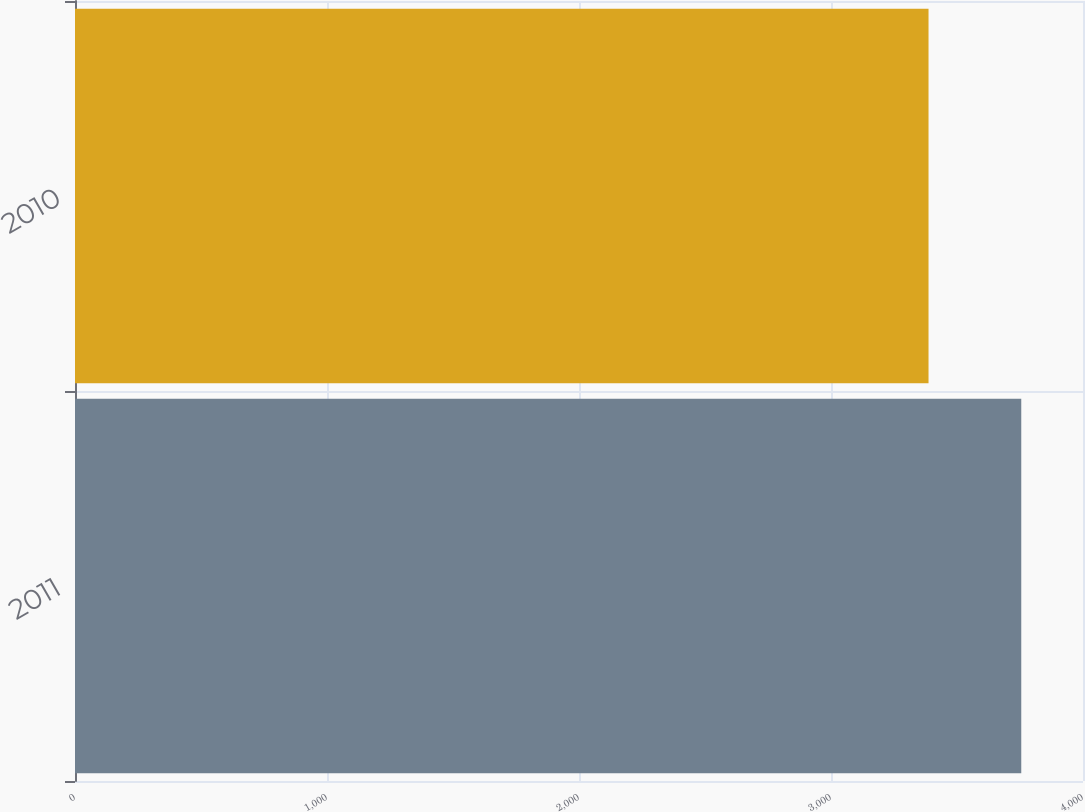Convert chart to OTSL. <chart><loc_0><loc_0><loc_500><loc_500><bar_chart><fcel>2011<fcel>2010<nl><fcel>3755<fcel>3387<nl></chart> 